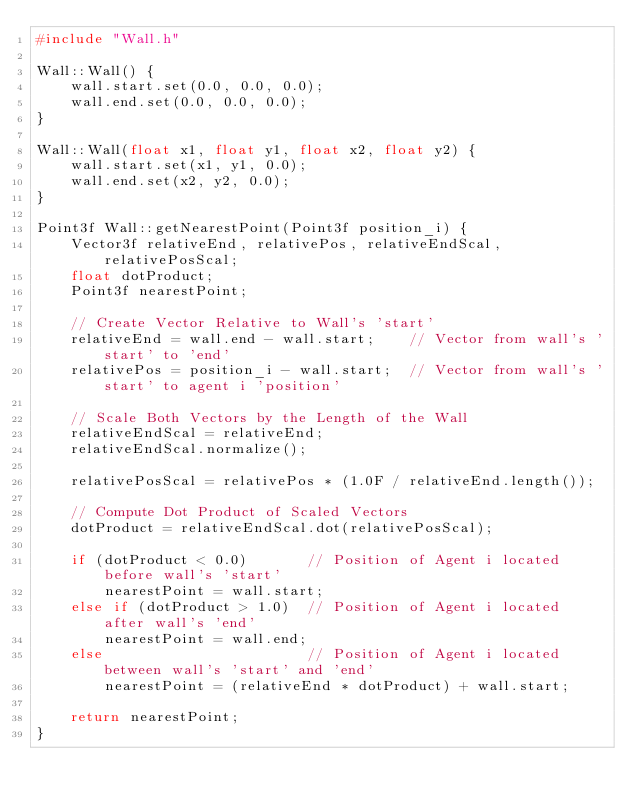<code> <loc_0><loc_0><loc_500><loc_500><_C++_>#include "Wall.h"

Wall::Wall() {
	wall.start.set(0.0, 0.0, 0.0);
	wall.end.set(0.0, 0.0, 0.0);
}

Wall::Wall(float x1, float y1, float x2, float y2) {
	wall.start.set(x1, y1, 0.0);
	wall.end.set(x2, y2, 0.0);
}

Point3f Wall::getNearestPoint(Point3f position_i) {
	Vector3f relativeEnd, relativePos, relativeEndScal, relativePosScal;
	float dotProduct;
	Point3f nearestPoint;

	// Create Vector Relative to Wall's 'start'
	relativeEnd = wall.end - wall.start;	// Vector from wall's 'start' to 'end'
	relativePos = position_i - wall.start;	// Vector from wall's 'start' to agent i 'position'

	// Scale Both Vectors by the Length of the Wall
	relativeEndScal = relativeEnd;
	relativeEndScal.normalize();

	relativePosScal = relativePos * (1.0F / relativeEnd.length());

	// Compute Dot Product of Scaled Vectors
	dotProduct = relativeEndScal.dot(relativePosScal);

	if (dotProduct < 0.0)		// Position of Agent i located before wall's 'start'
		nearestPoint = wall.start;
	else if (dotProduct > 1.0)	// Position of Agent i located after wall's 'end'
		nearestPoint = wall.end;
	else						// Position of Agent i located between wall's 'start' and 'end'
		nearestPoint = (relativeEnd * dotProduct) + wall.start;

	return nearestPoint;
}</code> 